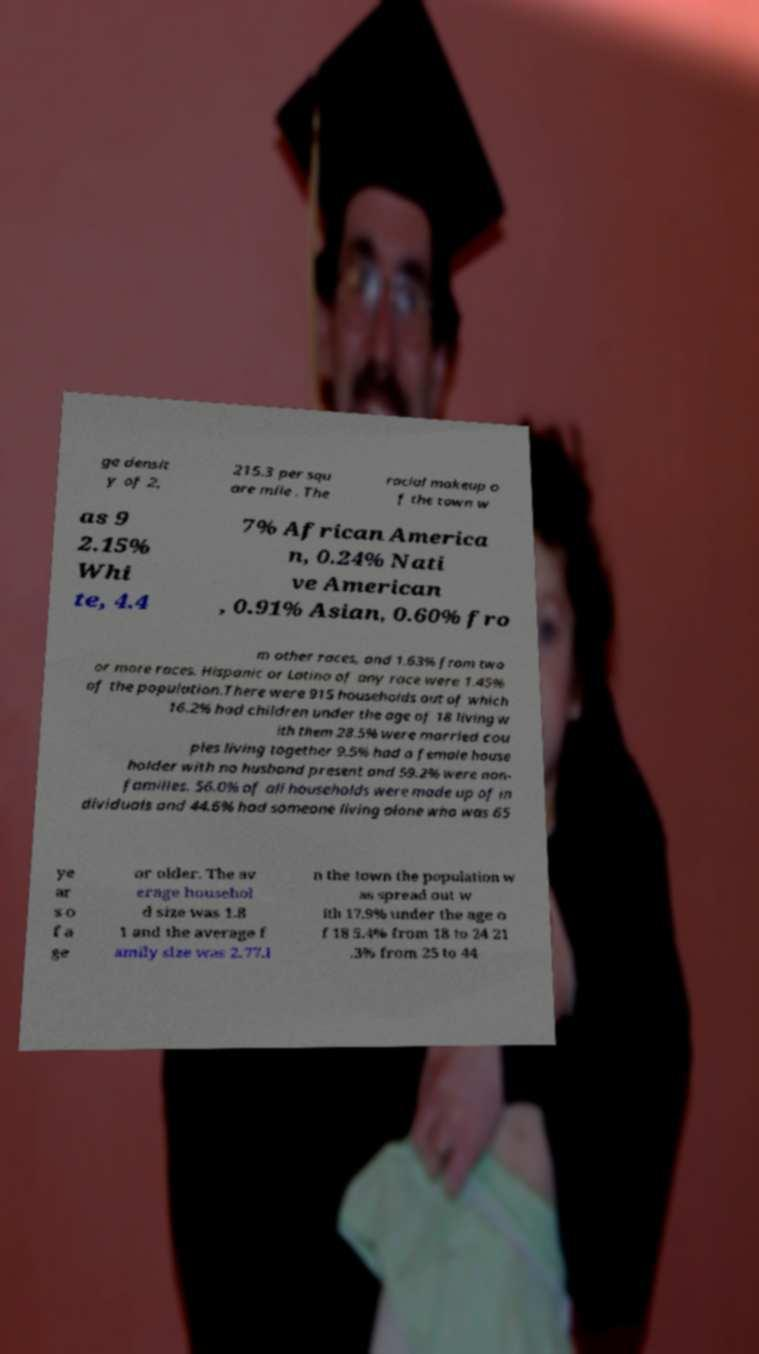Can you read and provide the text displayed in the image?This photo seems to have some interesting text. Can you extract and type it out for me? ge densit y of 2, 215.3 per squ are mile . The racial makeup o f the town w as 9 2.15% Whi te, 4.4 7% African America n, 0.24% Nati ve American , 0.91% Asian, 0.60% fro m other races, and 1.63% from two or more races. Hispanic or Latino of any race were 1.45% of the population.There were 915 households out of which 16.2% had children under the age of 18 living w ith them 28.5% were married cou ples living together 9.5% had a female house holder with no husband present and 59.2% were non- families. 56.0% of all households were made up of in dividuals and 44.6% had someone living alone who was 65 ye ar s o f a ge or older. The av erage househol d size was 1.8 1 and the average f amily size was 2.77.I n the town the population w as spread out w ith 17.9% under the age o f 18 5.4% from 18 to 24 21 .3% from 25 to 44 